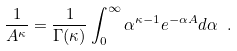Convert formula to latex. <formula><loc_0><loc_0><loc_500><loc_500>\frac { 1 } { A ^ { \kappa } } = \frac { 1 } { \Gamma ( \kappa ) } \int _ { 0 } ^ { \infty } \alpha ^ { \kappa - 1 } e ^ { - \alpha A } d \alpha \ .</formula> 